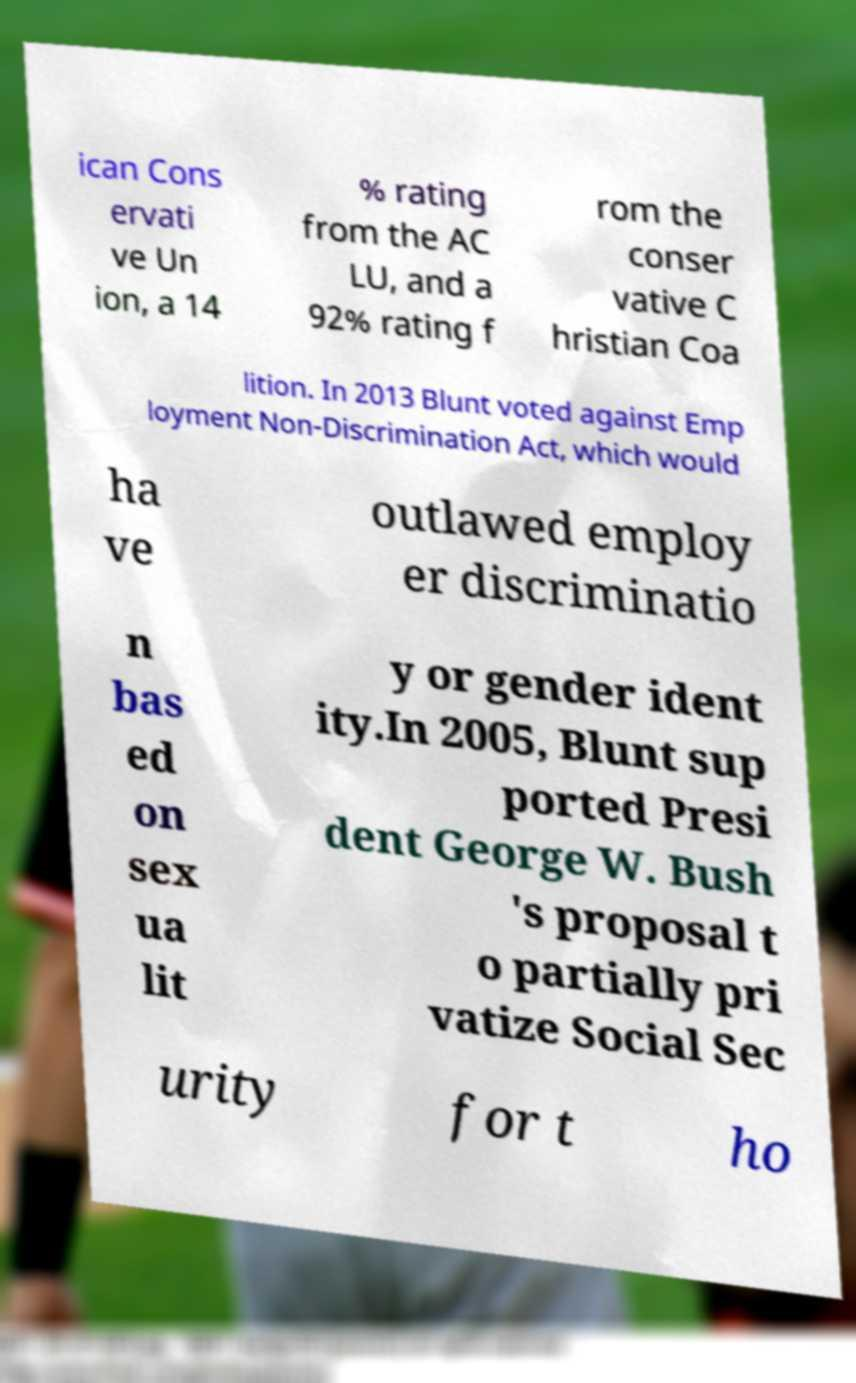Please identify and transcribe the text found in this image. ican Cons ervati ve Un ion, a 14 % rating from the AC LU, and a 92% rating f rom the conser vative C hristian Coa lition. In 2013 Blunt voted against Emp loyment Non-Discrimination Act, which would ha ve outlawed employ er discriminatio n bas ed on sex ua lit y or gender ident ity.In 2005, Blunt sup ported Presi dent George W. Bush 's proposal t o partially pri vatize Social Sec urity for t ho 